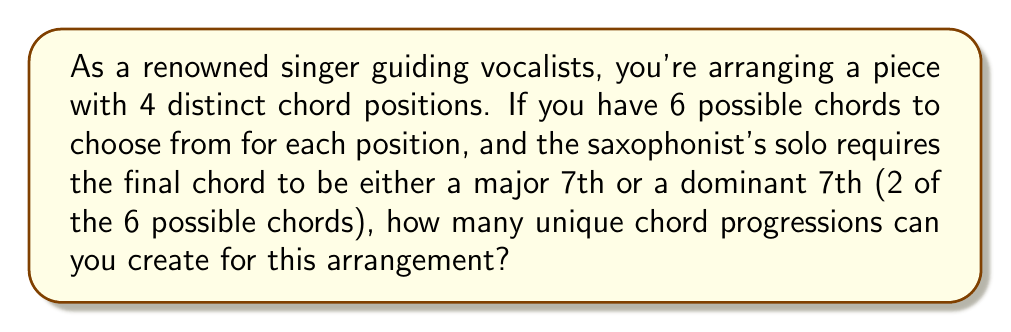Provide a solution to this math problem. Let's break this down step-by-step:

1) We have 4 chord positions in total.

2) For the first 3 positions, we have 6 choices for each:
   $$ 6 \times 6 \times 6 = 6^3 $$

3) For the last position, we're restricted to 2 choices (major 7th or dominant 7th).

4) Using the multiplication principle, we multiply the number of choices for each position:
   $$ 6^3 \times 2 = 216 \times 2 = 432 $$

5) Therefore, the total number of unique chord progressions is 432.

This calculation can be generalized as:
$$ n^{k-1} \times m $$
Where:
$n$ = number of chord choices for the first $k-1$ positions
$k$ = total number of chord positions
$m$ = number of chord choices for the final position
Answer: 432 